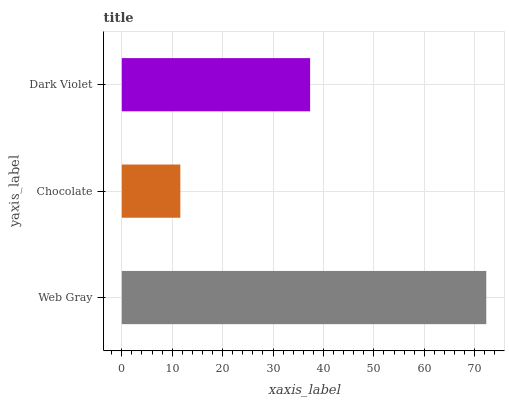Is Chocolate the minimum?
Answer yes or no. Yes. Is Web Gray the maximum?
Answer yes or no. Yes. Is Dark Violet the minimum?
Answer yes or no. No. Is Dark Violet the maximum?
Answer yes or no. No. Is Dark Violet greater than Chocolate?
Answer yes or no. Yes. Is Chocolate less than Dark Violet?
Answer yes or no. Yes. Is Chocolate greater than Dark Violet?
Answer yes or no. No. Is Dark Violet less than Chocolate?
Answer yes or no. No. Is Dark Violet the high median?
Answer yes or no. Yes. Is Dark Violet the low median?
Answer yes or no. Yes. Is Chocolate the high median?
Answer yes or no. No. Is Chocolate the low median?
Answer yes or no. No. 